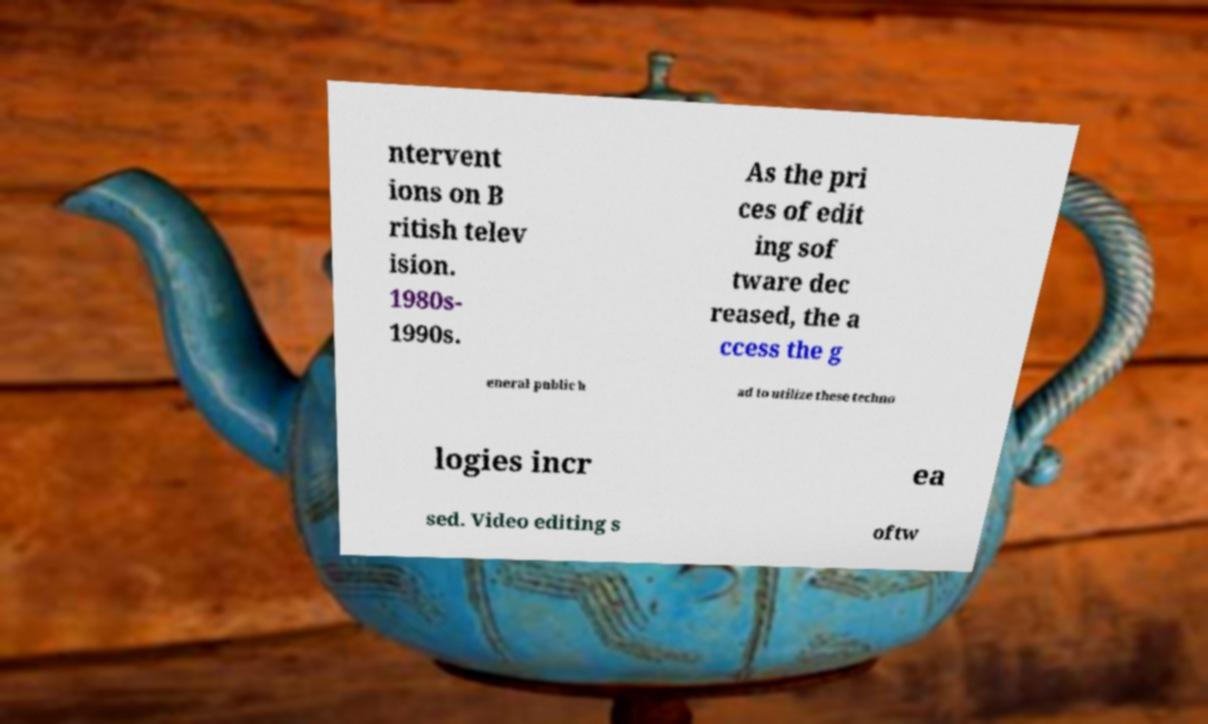Could you assist in decoding the text presented in this image and type it out clearly? ntervent ions on B ritish telev ision. 1980s- 1990s. As the pri ces of edit ing sof tware dec reased, the a ccess the g eneral public h ad to utilize these techno logies incr ea sed. Video editing s oftw 